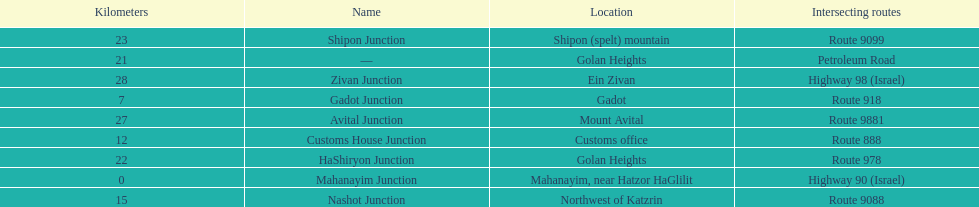What is the last junction on highway 91? Zivan Junction. 